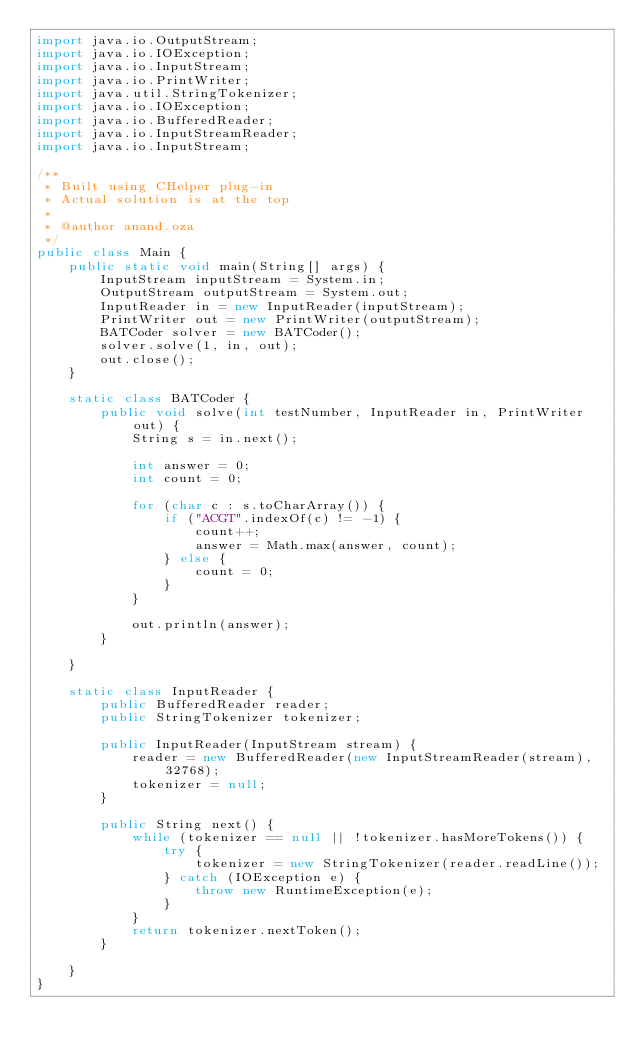Convert code to text. <code><loc_0><loc_0><loc_500><loc_500><_Java_>import java.io.OutputStream;
import java.io.IOException;
import java.io.InputStream;
import java.io.PrintWriter;
import java.util.StringTokenizer;
import java.io.IOException;
import java.io.BufferedReader;
import java.io.InputStreamReader;
import java.io.InputStream;

/**
 * Built using CHelper plug-in
 * Actual solution is at the top
 *
 * @author anand.oza
 */
public class Main {
    public static void main(String[] args) {
        InputStream inputStream = System.in;
        OutputStream outputStream = System.out;
        InputReader in = new InputReader(inputStream);
        PrintWriter out = new PrintWriter(outputStream);
        BATCoder solver = new BATCoder();
        solver.solve(1, in, out);
        out.close();
    }

    static class BATCoder {
        public void solve(int testNumber, InputReader in, PrintWriter out) {
            String s = in.next();

            int answer = 0;
            int count = 0;

            for (char c : s.toCharArray()) {
                if ("ACGT".indexOf(c) != -1) {
                    count++;
                    answer = Math.max(answer, count);
                } else {
                    count = 0;
                }
            }

            out.println(answer);
        }

    }

    static class InputReader {
        public BufferedReader reader;
        public StringTokenizer tokenizer;

        public InputReader(InputStream stream) {
            reader = new BufferedReader(new InputStreamReader(stream), 32768);
            tokenizer = null;
        }

        public String next() {
            while (tokenizer == null || !tokenizer.hasMoreTokens()) {
                try {
                    tokenizer = new StringTokenizer(reader.readLine());
                } catch (IOException e) {
                    throw new RuntimeException(e);
                }
            }
            return tokenizer.nextToken();
        }

    }
}

</code> 